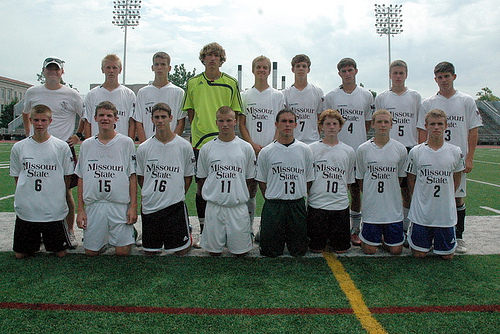<image>
Is there a green boy behind the player? Yes. From this viewpoint, the green boy is positioned behind the player, with the player partially or fully occluding the green boy. 